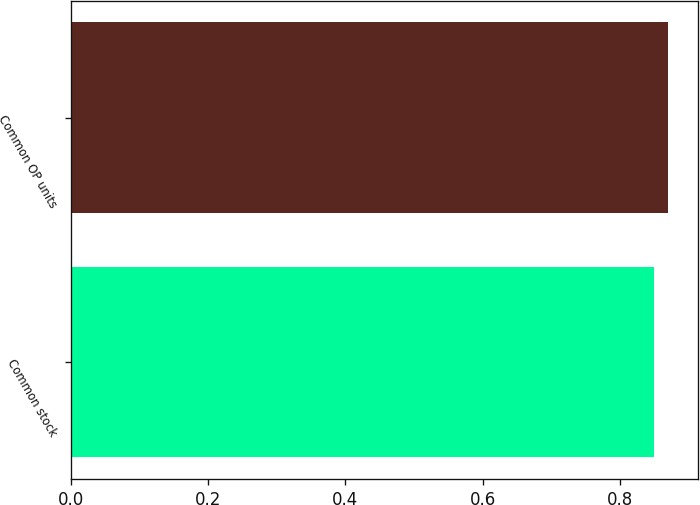Convert chart to OTSL. <chart><loc_0><loc_0><loc_500><loc_500><bar_chart><fcel>Common stock<fcel>Common OP units<nl><fcel>0.85<fcel>0.87<nl></chart> 